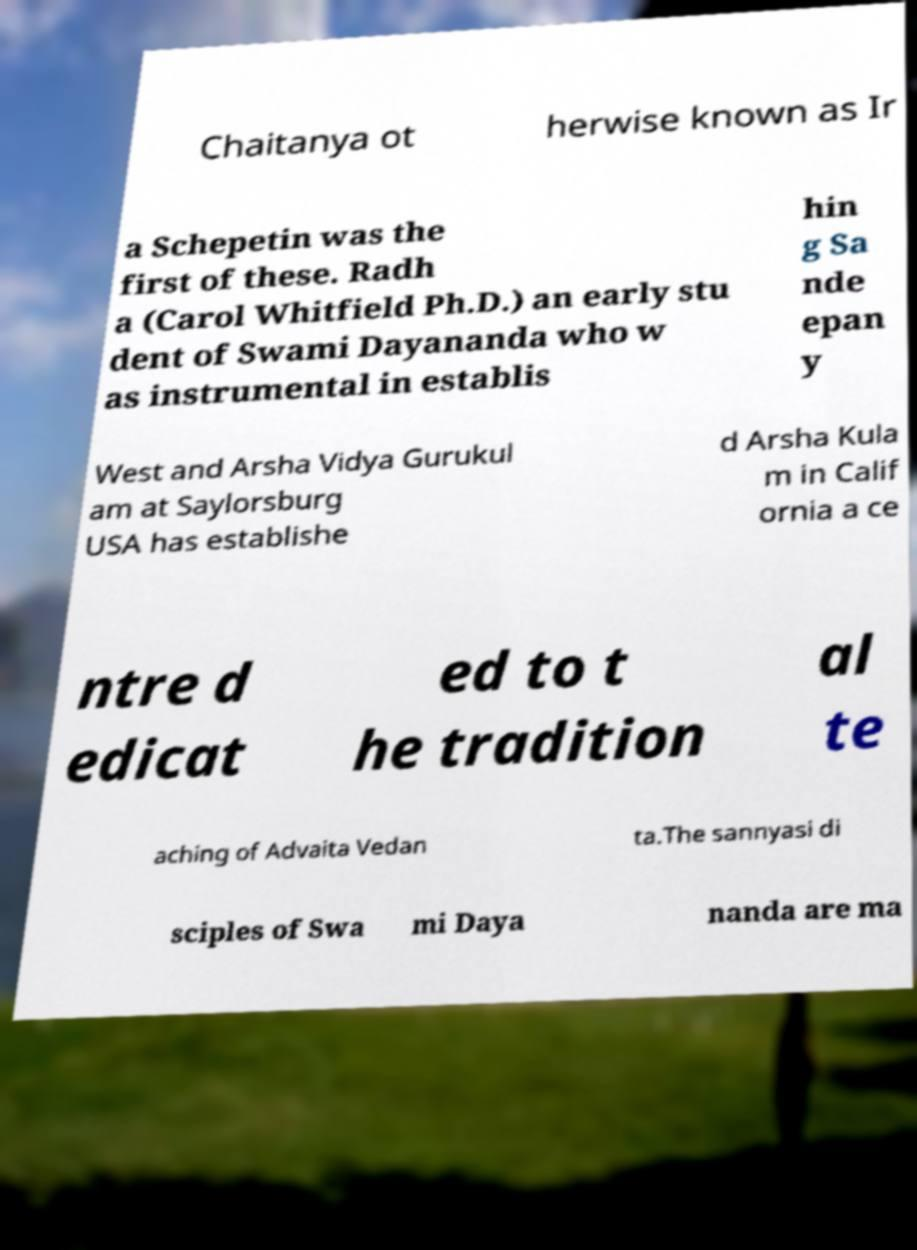Please identify and transcribe the text found in this image. Chaitanya ot herwise known as Ir a Schepetin was the first of these. Radh a (Carol Whitfield Ph.D.) an early stu dent of Swami Dayananda who w as instrumental in establis hin g Sa nde epan y West and Arsha Vidya Gurukul am at Saylorsburg USA has establishe d Arsha Kula m in Calif ornia a ce ntre d edicat ed to t he tradition al te aching of Advaita Vedan ta.The sannyasi di sciples of Swa mi Daya nanda are ma 